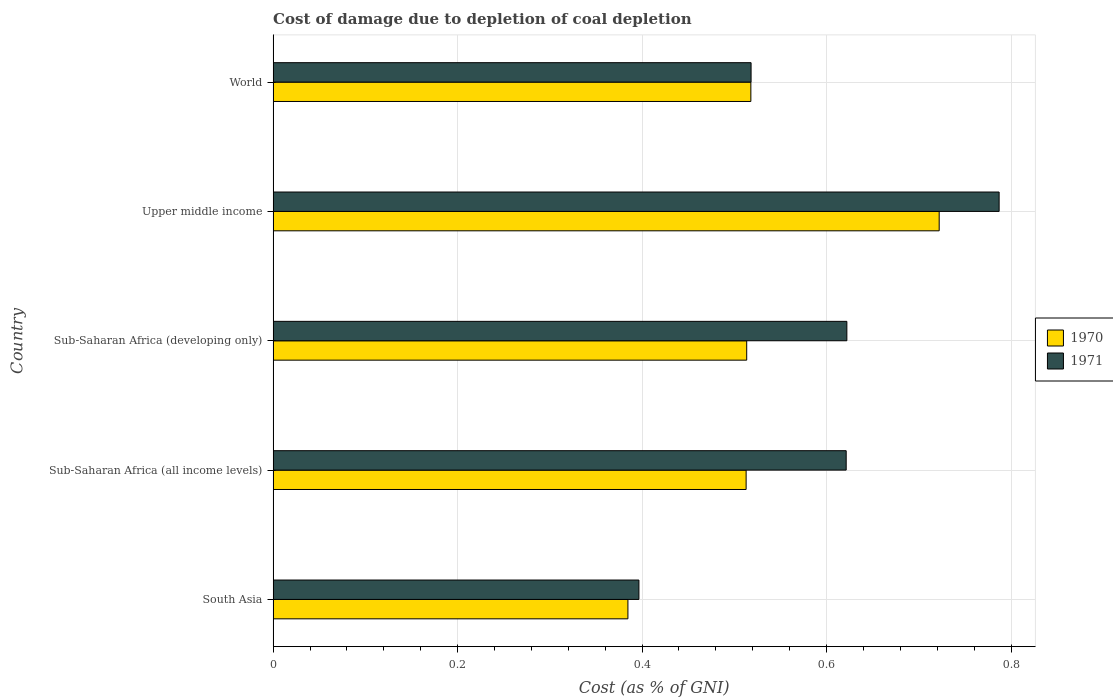How many groups of bars are there?
Keep it short and to the point. 5. Are the number of bars per tick equal to the number of legend labels?
Offer a terse response. Yes. Are the number of bars on each tick of the Y-axis equal?
Your answer should be compact. Yes. How many bars are there on the 5th tick from the top?
Make the answer very short. 2. How many bars are there on the 3rd tick from the bottom?
Keep it short and to the point. 2. What is the label of the 1st group of bars from the top?
Provide a succinct answer. World. What is the cost of damage caused due to coal depletion in 1970 in Sub-Saharan Africa (all income levels)?
Give a very brief answer. 0.51. Across all countries, what is the maximum cost of damage caused due to coal depletion in 1971?
Your answer should be compact. 0.79. Across all countries, what is the minimum cost of damage caused due to coal depletion in 1970?
Provide a succinct answer. 0.38. In which country was the cost of damage caused due to coal depletion in 1970 maximum?
Keep it short and to the point. Upper middle income. What is the total cost of damage caused due to coal depletion in 1970 in the graph?
Keep it short and to the point. 2.65. What is the difference between the cost of damage caused due to coal depletion in 1971 in Sub-Saharan Africa (developing only) and that in World?
Your response must be concise. 0.1. What is the difference between the cost of damage caused due to coal depletion in 1971 in Sub-Saharan Africa (all income levels) and the cost of damage caused due to coal depletion in 1970 in Sub-Saharan Africa (developing only)?
Keep it short and to the point. 0.11. What is the average cost of damage caused due to coal depletion in 1970 per country?
Offer a very short reply. 0.53. What is the difference between the cost of damage caused due to coal depletion in 1971 and cost of damage caused due to coal depletion in 1970 in Upper middle income?
Your response must be concise. 0.06. What is the ratio of the cost of damage caused due to coal depletion in 1970 in Sub-Saharan Africa (all income levels) to that in World?
Provide a short and direct response. 0.99. What is the difference between the highest and the second highest cost of damage caused due to coal depletion in 1971?
Your answer should be very brief. 0.17. What is the difference between the highest and the lowest cost of damage caused due to coal depletion in 1971?
Provide a succinct answer. 0.39. Are all the bars in the graph horizontal?
Give a very brief answer. Yes. What is the difference between two consecutive major ticks on the X-axis?
Your response must be concise. 0.2. Does the graph contain any zero values?
Offer a very short reply. No. How many legend labels are there?
Your response must be concise. 2. How are the legend labels stacked?
Your answer should be compact. Vertical. What is the title of the graph?
Provide a short and direct response. Cost of damage due to depletion of coal depletion. Does "1967" appear as one of the legend labels in the graph?
Your answer should be compact. No. What is the label or title of the X-axis?
Ensure brevity in your answer.  Cost (as % of GNI). What is the Cost (as % of GNI) of 1970 in South Asia?
Your answer should be very brief. 0.38. What is the Cost (as % of GNI) in 1971 in South Asia?
Make the answer very short. 0.4. What is the Cost (as % of GNI) in 1970 in Sub-Saharan Africa (all income levels)?
Offer a very short reply. 0.51. What is the Cost (as % of GNI) of 1971 in Sub-Saharan Africa (all income levels)?
Offer a terse response. 0.62. What is the Cost (as % of GNI) of 1970 in Sub-Saharan Africa (developing only)?
Your response must be concise. 0.51. What is the Cost (as % of GNI) of 1971 in Sub-Saharan Africa (developing only)?
Ensure brevity in your answer.  0.62. What is the Cost (as % of GNI) of 1970 in Upper middle income?
Provide a short and direct response. 0.72. What is the Cost (as % of GNI) in 1971 in Upper middle income?
Provide a succinct answer. 0.79. What is the Cost (as % of GNI) of 1970 in World?
Give a very brief answer. 0.52. What is the Cost (as % of GNI) in 1971 in World?
Make the answer very short. 0.52. Across all countries, what is the maximum Cost (as % of GNI) of 1970?
Your answer should be compact. 0.72. Across all countries, what is the maximum Cost (as % of GNI) in 1971?
Provide a short and direct response. 0.79. Across all countries, what is the minimum Cost (as % of GNI) in 1970?
Offer a terse response. 0.38. Across all countries, what is the minimum Cost (as % of GNI) in 1971?
Ensure brevity in your answer.  0.4. What is the total Cost (as % of GNI) of 1970 in the graph?
Your answer should be very brief. 2.65. What is the total Cost (as % of GNI) in 1971 in the graph?
Offer a very short reply. 2.94. What is the difference between the Cost (as % of GNI) of 1970 in South Asia and that in Sub-Saharan Africa (all income levels)?
Provide a succinct answer. -0.13. What is the difference between the Cost (as % of GNI) of 1971 in South Asia and that in Sub-Saharan Africa (all income levels)?
Give a very brief answer. -0.22. What is the difference between the Cost (as % of GNI) in 1970 in South Asia and that in Sub-Saharan Africa (developing only)?
Offer a terse response. -0.13. What is the difference between the Cost (as % of GNI) in 1971 in South Asia and that in Sub-Saharan Africa (developing only)?
Ensure brevity in your answer.  -0.23. What is the difference between the Cost (as % of GNI) of 1970 in South Asia and that in Upper middle income?
Provide a short and direct response. -0.34. What is the difference between the Cost (as % of GNI) in 1971 in South Asia and that in Upper middle income?
Your response must be concise. -0.39. What is the difference between the Cost (as % of GNI) of 1970 in South Asia and that in World?
Make the answer very short. -0.13. What is the difference between the Cost (as % of GNI) of 1971 in South Asia and that in World?
Offer a terse response. -0.12. What is the difference between the Cost (as % of GNI) in 1970 in Sub-Saharan Africa (all income levels) and that in Sub-Saharan Africa (developing only)?
Give a very brief answer. -0. What is the difference between the Cost (as % of GNI) of 1971 in Sub-Saharan Africa (all income levels) and that in Sub-Saharan Africa (developing only)?
Provide a succinct answer. -0. What is the difference between the Cost (as % of GNI) of 1970 in Sub-Saharan Africa (all income levels) and that in Upper middle income?
Offer a terse response. -0.21. What is the difference between the Cost (as % of GNI) of 1971 in Sub-Saharan Africa (all income levels) and that in Upper middle income?
Give a very brief answer. -0.17. What is the difference between the Cost (as % of GNI) in 1970 in Sub-Saharan Africa (all income levels) and that in World?
Offer a terse response. -0.01. What is the difference between the Cost (as % of GNI) in 1971 in Sub-Saharan Africa (all income levels) and that in World?
Your response must be concise. 0.1. What is the difference between the Cost (as % of GNI) of 1970 in Sub-Saharan Africa (developing only) and that in Upper middle income?
Make the answer very short. -0.21. What is the difference between the Cost (as % of GNI) of 1971 in Sub-Saharan Africa (developing only) and that in Upper middle income?
Your answer should be very brief. -0.17. What is the difference between the Cost (as % of GNI) of 1970 in Sub-Saharan Africa (developing only) and that in World?
Keep it short and to the point. -0. What is the difference between the Cost (as % of GNI) of 1971 in Sub-Saharan Africa (developing only) and that in World?
Your answer should be very brief. 0.1. What is the difference between the Cost (as % of GNI) of 1970 in Upper middle income and that in World?
Your answer should be very brief. 0.2. What is the difference between the Cost (as % of GNI) of 1971 in Upper middle income and that in World?
Give a very brief answer. 0.27. What is the difference between the Cost (as % of GNI) of 1970 in South Asia and the Cost (as % of GNI) of 1971 in Sub-Saharan Africa (all income levels)?
Your answer should be compact. -0.24. What is the difference between the Cost (as % of GNI) in 1970 in South Asia and the Cost (as % of GNI) in 1971 in Sub-Saharan Africa (developing only)?
Provide a succinct answer. -0.24. What is the difference between the Cost (as % of GNI) of 1970 in South Asia and the Cost (as % of GNI) of 1971 in Upper middle income?
Make the answer very short. -0.4. What is the difference between the Cost (as % of GNI) of 1970 in South Asia and the Cost (as % of GNI) of 1971 in World?
Provide a succinct answer. -0.13. What is the difference between the Cost (as % of GNI) of 1970 in Sub-Saharan Africa (all income levels) and the Cost (as % of GNI) of 1971 in Sub-Saharan Africa (developing only)?
Give a very brief answer. -0.11. What is the difference between the Cost (as % of GNI) in 1970 in Sub-Saharan Africa (all income levels) and the Cost (as % of GNI) in 1971 in Upper middle income?
Provide a short and direct response. -0.27. What is the difference between the Cost (as % of GNI) in 1970 in Sub-Saharan Africa (all income levels) and the Cost (as % of GNI) in 1971 in World?
Offer a terse response. -0.01. What is the difference between the Cost (as % of GNI) in 1970 in Sub-Saharan Africa (developing only) and the Cost (as % of GNI) in 1971 in Upper middle income?
Offer a very short reply. -0.27. What is the difference between the Cost (as % of GNI) in 1970 in Sub-Saharan Africa (developing only) and the Cost (as % of GNI) in 1971 in World?
Make the answer very short. -0. What is the difference between the Cost (as % of GNI) of 1970 in Upper middle income and the Cost (as % of GNI) of 1971 in World?
Ensure brevity in your answer.  0.2. What is the average Cost (as % of GNI) in 1970 per country?
Your response must be concise. 0.53. What is the average Cost (as % of GNI) of 1971 per country?
Provide a succinct answer. 0.59. What is the difference between the Cost (as % of GNI) in 1970 and Cost (as % of GNI) in 1971 in South Asia?
Provide a succinct answer. -0.01. What is the difference between the Cost (as % of GNI) in 1970 and Cost (as % of GNI) in 1971 in Sub-Saharan Africa (all income levels)?
Keep it short and to the point. -0.11. What is the difference between the Cost (as % of GNI) of 1970 and Cost (as % of GNI) of 1971 in Sub-Saharan Africa (developing only)?
Your answer should be compact. -0.11. What is the difference between the Cost (as % of GNI) of 1970 and Cost (as % of GNI) of 1971 in Upper middle income?
Your response must be concise. -0.07. What is the difference between the Cost (as % of GNI) in 1970 and Cost (as % of GNI) in 1971 in World?
Your response must be concise. -0. What is the ratio of the Cost (as % of GNI) in 1970 in South Asia to that in Sub-Saharan Africa (all income levels)?
Ensure brevity in your answer.  0.75. What is the ratio of the Cost (as % of GNI) of 1971 in South Asia to that in Sub-Saharan Africa (all income levels)?
Provide a short and direct response. 0.64. What is the ratio of the Cost (as % of GNI) in 1970 in South Asia to that in Sub-Saharan Africa (developing only)?
Offer a very short reply. 0.75. What is the ratio of the Cost (as % of GNI) of 1971 in South Asia to that in Sub-Saharan Africa (developing only)?
Your answer should be very brief. 0.64. What is the ratio of the Cost (as % of GNI) in 1970 in South Asia to that in Upper middle income?
Your response must be concise. 0.53. What is the ratio of the Cost (as % of GNI) in 1971 in South Asia to that in Upper middle income?
Your response must be concise. 0.5. What is the ratio of the Cost (as % of GNI) in 1970 in South Asia to that in World?
Your response must be concise. 0.74. What is the ratio of the Cost (as % of GNI) in 1971 in South Asia to that in World?
Give a very brief answer. 0.77. What is the ratio of the Cost (as % of GNI) in 1971 in Sub-Saharan Africa (all income levels) to that in Sub-Saharan Africa (developing only)?
Provide a short and direct response. 1. What is the ratio of the Cost (as % of GNI) of 1970 in Sub-Saharan Africa (all income levels) to that in Upper middle income?
Offer a very short reply. 0.71. What is the ratio of the Cost (as % of GNI) in 1971 in Sub-Saharan Africa (all income levels) to that in Upper middle income?
Your answer should be compact. 0.79. What is the ratio of the Cost (as % of GNI) of 1970 in Sub-Saharan Africa (all income levels) to that in World?
Offer a terse response. 0.99. What is the ratio of the Cost (as % of GNI) of 1971 in Sub-Saharan Africa (all income levels) to that in World?
Give a very brief answer. 1.2. What is the ratio of the Cost (as % of GNI) of 1970 in Sub-Saharan Africa (developing only) to that in Upper middle income?
Provide a succinct answer. 0.71. What is the ratio of the Cost (as % of GNI) in 1971 in Sub-Saharan Africa (developing only) to that in Upper middle income?
Keep it short and to the point. 0.79. What is the ratio of the Cost (as % of GNI) of 1971 in Sub-Saharan Africa (developing only) to that in World?
Offer a terse response. 1.2. What is the ratio of the Cost (as % of GNI) of 1970 in Upper middle income to that in World?
Provide a short and direct response. 1.39. What is the ratio of the Cost (as % of GNI) of 1971 in Upper middle income to that in World?
Provide a succinct answer. 1.52. What is the difference between the highest and the second highest Cost (as % of GNI) in 1970?
Your response must be concise. 0.2. What is the difference between the highest and the second highest Cost (as % of GNI) of 1971?
Offer a very short reply. 0.17. What is the difference between the highest and the lowest Cost (as % of GNI) of 1970?
Offer a terse response. 0.34. What is the difference between the highest and the lowest Cost (as % of GNI) of 1971?
Provide a short and direct response. 0.39. 